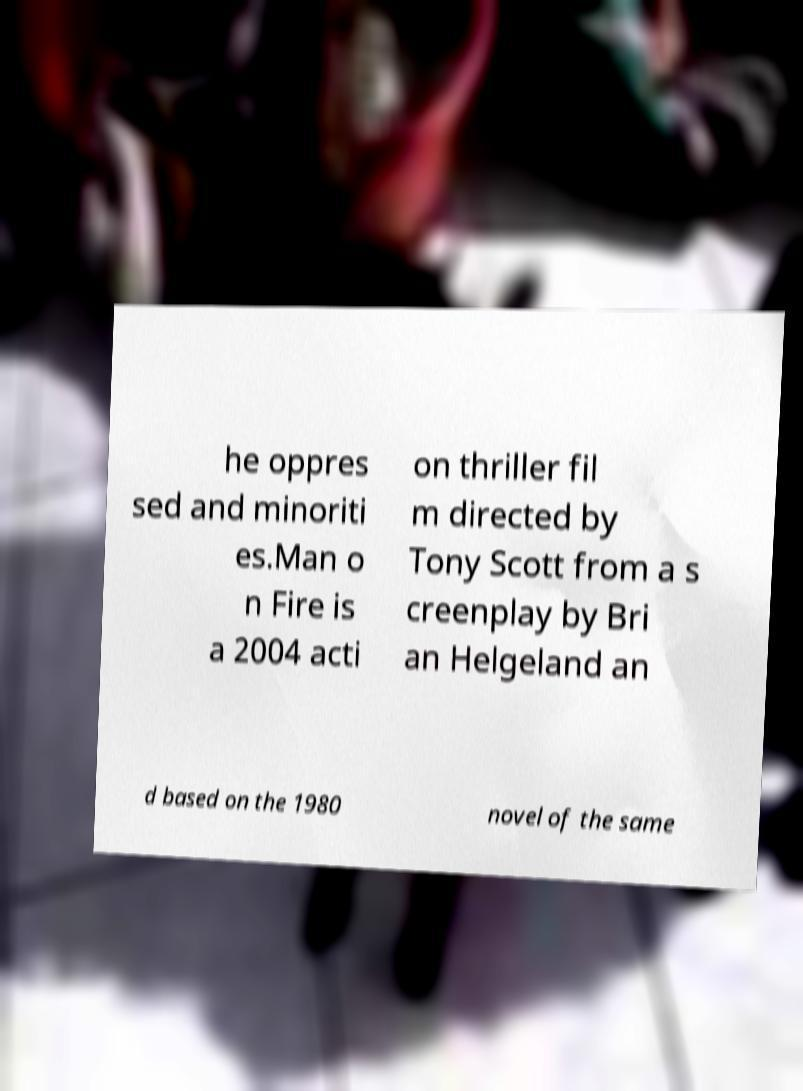Can you read and provide the text displayed in the image?This photo seems to have some interesting text. Can you extract and type it out for me? he oppres sed and minoriti es.Man o n Fire is a 2004 acti on thriller fil m directed by Tony Scott from a s creenplay by Bri an Helgeland an d based on the 1980 novel of the same 